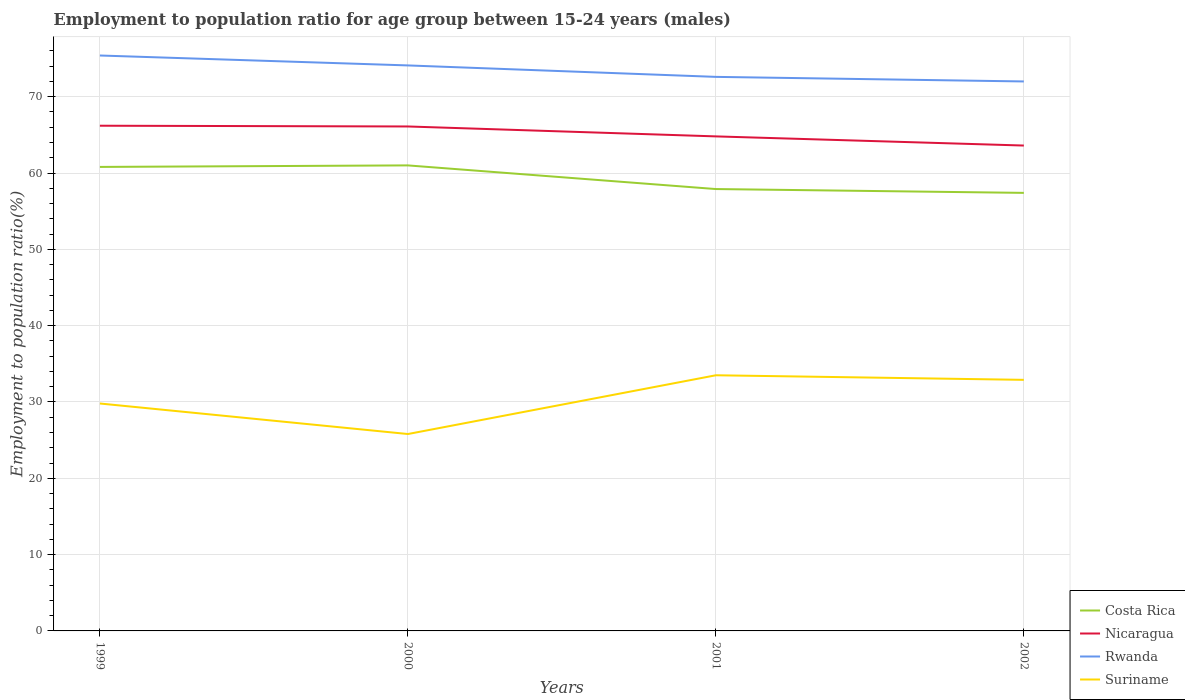How many different coloured lines are there?
Provide a short and direct response. 4. Is the number of lines equal to the number of legend labels?
Your answer should be very brief. Yes. Across all years, what is the maximum employment to population ratio in Suriname?
Make the answer very short. 25.8. In which year was the employment to population ratio in Rwanda maximum?
Make the answer very short. 2002. What is the total employment to population ratio in Suriname in the graph?
Keep it short and to the point. -7.7. What is the difference between the highest and the second highest employment to population ratio in Nicaragua?
Make the answer very short. 2.6. How many lines are there?
Make the answer very short. 4. How many years are there in the graph?
Give a very brief answer. 4. How are the legend labels stacked?
Offer a terse response. Vertical. What is the title of the graph?
Ensure brevity in your answer.  Employment to population ratio for age group between 15-24 years (males). Does "Low income" appear as one of the legend labels in the graph?
Ensure brevity in your answer.  No. What is the label or title of the Y-axis?
Give a very brief answer. Employment to population ratio(%). What is the Employment to population ratio(%) of Costa Rica in 1999?
Provide a succinct answer. 60.8. What is the Employment to population ratio(%) in Nicaragua in 1999?
Your answer should be compact. 66.2. What is the Employment to population ratio(%) of Rwanda in 1999?
Keep it short and to the point. 75.4. What is the Employment to population ratio(%) of Suriname in 1999?
Your answer should be compact. 29.8. What is the Employment to population ratio(%) of Nicaragua in 2000?
Ensure brevity in your answer.  66.1. What is the Employment to population ratio(%) in Rwanda in 2000?
Make the answer very short. 74.1. What is the Employment to population ratio(%) in Suriname in 2000?
Offer a terse response. 25.8. What is the Employment to population ratio(%) of Costa Rica in 2001?
Provide a succinct answer. 57.9. What is the Employment to population ratio(%) of Nicaragua in 2001?
Make the answer very short. 64.8. What is the Employment to population ratio(%) of Rwanda in 2001?
Ensure brevity in your answer.  72.6. What is the Employment to population ratio(%) in Suriname in 2001?
Make the answer very short. 33.5. What is the Employment to population ratio(%) of Costa Rica in 2002?
Offer a very short reply. 57.4. What is the Employment to population ratio(%) in Nicaragua in 2002?
Provide a short and direct response. 63.6. What is the Employment to population ratio(%) of Rwanda in 2002?
Offer a very short reply. 72. What is the Employment to population ratio(%) in Suriname in 2002?
Your answer should be very brief. 32.9. Across all years, what is the maximum Employment to population ratio(%) in Nicaragua?
Offer a terse response. 66.2. Across all years, what is the maximum Employment to population ratio(%) in Rwanda?
Your response must be concise. 75.4. Across all years, what is the maximum Employment to population ratio(%) in Suriname?
Give a very brief answer. 33.5. Across all years, what is the minimum Employment to population ratio(%) in Costa Rica?
Give a very brief answer. 57.4. Across all years, what is the minimum Employment to population ratio(%) of Nicaragua?
Your answer should be very brief. 63.6. Across all years, what is the minimum Employment to population ratio(%) of Suriname?
Provide a succinct answer. 25.8. What is the total Employment to population ratio(%) of Costa Rica in the graph?
Your answer should be very brief. 237.1. What is the total Employment to population ratio(%) of Nicaragua in the graph?
Your response must be concise. 260.7. What is the total Employment to population ratio(%) in Rwanda in the graph?
Offer a very short reply. 294.1. What is the total Employment to population ratio(%) of Suriname in the graph?
Provide a short and direct response. 122. What is the difference between the Employment to population ratio(%) in Rwanda in 1999 and that in 2000?
Provide a short and direct response. 1.3. What is the difference between the Employment to population ratio(%) in Costa Rica in 1999 and that in 2001?
Your response must be concise. 2.9. What is the difference between the Employment to population ratio(%) of Rwanda in 1999 and that in 2001?
Provide a succinct answer. 2.8. What is the difference between the Employment to population ratio(%) of Rwanda in 1999 and that in 2002?
Keep it short and to the point. 3.4. What is the difference between the Employment to population ratio(%) in Costa Rica in 2000 and that in 2001?
Your answer should be compact. 3.1. What is the difference between the Employment to population ratio(%) in Nicaragua in 2000 and that in 2002?
Ensure brevity in your answer.  2.5. What is the difference between the Employment to population ratio(%) of Rwanda in 2001 and that in 2002?
Your response must be concise. 0.6. What is the difference between the Employment to population ratio(%) in Suriname in 2001 and that in 2002?
Provide a short and direct response. 0.6. What is the difference between the Employment to population ratio(%) of Costa Rica in 1999 and the Employment to population ratio(%) of Nicaragua in 2000?
Offer a very short reply. -5.3. What is the difference between the Employment to population ratio(%) in Costa Rica in 1999 and the Employment to population ratio(%) in Rwanda in 2000?
Your answer should be compact. -13.3. What is the difference between the Employment to population ratio(%) in Costa Rica in 1999 and the Employment to population ratio(%) in Suriname in 2000?
Give a very brief answer. 35. What is the difference between the Employment to population ratio(%) of Nicaragua in 1999 and the Employment to population ratio(%) of Suriname in 2000?
Provide a succinct answer. 40.4. What is the difference between the Employment to population ratio(%) in Rwanda in 1999 and the Employment to population ratio(%) in Suriname in 2000?
Keep it short and to the point. 49.6. What is the difference between the Employment to population ratio(%) of Costa Rica in 1999 and the Employment to population ratio(%) of Nicaragua in 2001?
Provide a short and direct response. -4. What is the difference between the Employment to population ratio(%) in Costa Rica in 1999 and the Employment to population ratio(%) in Suriname in 2001?
Ensure brevity in your answer.  27.3. What is the difference between the Employment to population ratio(%) of Nicaragua in 1999 and the Employment to population ratio(%) of Suriname in 2001?
Give a very brief answer. 32.7. What is the difference between the Employment to population ratio(%) of Rwanda in 1999 and the Employment to population ratio(%) of Suriname in 2001?
Your answer should be very brief. 41.9. What is the difference between the Employment to population ratio(%) in Costa Rica in 1999 and the Employment to population ratio(%) in Nicaragua in 2002?
Keep it short and to the point. -2.8. What is the difference between the Employment to population ratio(%) in Costa Rica in 1999 and the Employment to population ratio(%) in Suriname in 2002?
Provide a succinct answer. 27.9. What is the difference between the Employment to population ratio(%) in Nicaragua in 1999 and the Employment to population ratio(%) in Suriname in 2002?
Provide a succinct answer. 33.3. What is the difference between the Employment to population ratio(%) of Rwanda in 1999 and the Employment to population ratio(%) of Suriname in 2002?
Your answer should be compact. 42.5. What is the difference between the Employment to population ratio(%) of Costa Rica in 2000 and the Employment to population ratio(%) of Nicaragua in 2001?
Your answer should be very brief. -3.8. What is the difference between the Employment to population ratio(%) in Nicaragua in 2000 and the Employment to population ratio(%) in Rwanda in 2001?
Provide a short and direct response. -6.5. What is the difference between the Employment to population ratio(%) in Nicaragua in 2000 and the Employment to population ratio(%) in Suriname in 2001?
Offer a terse response. 32.6. What is the difference between the Employment to population ratio(%) of Rwanda in 2000 and the Employment to population ratio(%) of Suriname in 2001?
Make the answer very short. 40.6. What is the difference between the Employment to population ratio(%) of Costa Rica in 2000 and the Employment to population ratio(%) of Nicaragua in 2002?
Offer a terse response. -2.6. What is the difference between the Employment to population ratio(%) in Costa Rica in 2000 and the Employment to population ratio(%) in Suriname in 2002?
Keep it short and to the point. 28.1. What is the difference between the Employment to population ratio(%) of Nicaragua in 2000 and the Employment to population ratio(%) of Suriname in 2002?
Your response must be concise. 33.2. What is the difference between the Employment to population ratio(%) of Rwanda in 2000 and the Employment to population ratio(%) of Suriname in 2002?
Provide a succinct answer. 41.2. What is the difference between the Employment to population ratio(%) in Costa Rica in 2001 and the Employment to population ratio(%) in Rwanda in 2002?
Make the answer very short. -14.1. What is the difference between the Employment to population ratio(%) of Nicaragua in 2001 and the Employment to population ratio(%) of Rwanda in 2002?
Provide a short and direct response. -7.2. What is the difference between the Employment to population ratio(%) of Nicaragua in 2001 and the Employment to population ratio(%) of Suriname in 2002?
Your answer should be compact. 31.9. What is the difference between the Employment to population ratio(%) in Rwanda in 2001 and the Employment to population ratio(%) in Suriname in 2002?
Give a very brief answer. 39.7. What is the average Employment to population ratio(%) of Costa Rica per year?
Provide a short and direct response. 59.27. What is the average Employment to population ratio(%) in Nicaragua per year?
Provide a short and direct response. 65.17. What is the average Employment to population ratio(%) of Rwanda per year?
Offer a terse response. 73.53. What is the average Employment to population ratio(%) in Suriname per year?
Make the answer very short. 30.5. In the year 1999, what is the difference between the Employment to population ratio(%) of Costa Rica and Employment to population ratio(%) of Nicaragua?
Your answer should be very brief. -5.4. In the year 1999, what is the difference between the Employment to population ratio(%) of Costa Rica and Employment to population ratio(%) of Rwanda?
Offer a very short reply. -14.6. In the year 1999, what is the difference between the Employment to population ratio(%) in Costa Rica and Employment to population ratio(%) in Suriname?
Offer a terse response. 31. In the year 1999, what is the difference between the Employment to population ratio(%) of Nicaragua and Employment to population ratio(%) of Rwanda?
Give a very brief answer. -9.2. In the year 1999, what is the difference between the Employment to population ratio(%) in Nicaragua and Employment to population ratio(%) in Suriname?
Your answer should be compact. 36.4. In the year 1999, what is the difference between the Employment to population ratio(%) in Rwanda and Employment to population ratio(%) in Suriname?
Keep it short and to the point. 45.6. In the year 2000, what is the difference between the Employment to population ratio(%) of Costa Rica and Employment to population ratio(%) of Suriname?
Keep it short and to the point. 35.2. In the year 2000, what is the difference between the Employment to population ratio(%) in Nicaragua and Employment to population ratio(%) in Suriname?
Ensure brevity in your answer.  40.3. In the year 2000, what is the difference between the Employment to population ratio(%) of Rwanda and Employment to population ratio(%) of Suriname?
Your response must be concise. 48.3. In the year 2001, what is the difference between the Employment to population ratio(%) in Costa Rica and Employment to population ratio(%) in Rwanda?
Your answer should be compact. -14.7. In the year 2001, what is the difference between the Employment to population ratio(%) in Costa Rica and Employment to population ratio(%) in Suriname?
Offer a terse response. 24.4. In the year 2001, what is the difference between the Employment to population ratio(%) in Nicaragua and Employment to population ratio(%) in Suriname?
Give a very brief answer. 31.3. In the year 2001, what is the difference between the Employment to population ratio(%) of Rwanda and Employment to population ratio(%) of Suriname?
Provide a short and direct response. 39.1. In the year 2002, what is the difference between the Employment to population ratio(%) of Costa Rica and Employment to population ratio(%) of Rwanda?
Offer a very short reply. -14.6. In the year 2002, what is the difference between the Employment to population ratio(%) of Nicaragua and Employment to population ratio(%) of Suriname?
Ensure brevity in your answer.  30.7. In the year 2002, what is the difference between the Employment to population ratio(%) in Rwanda and Employment to population ratio(%) in Suriname?
Your answer should be compact. 39.1. What is the ratio of the Employment to population ratio(%) of Costa Rica in 1999 to that in 2000?
Make the answer very short. 1. What is the ratio of the Employment to population ratio(%) of Nicaragua in 1999 to that in 2000?
Keep it short and to the point. 1. What is the ratio of the Employment to population ratio(%) in Rwanda in 1999 to that in 2000?
Provide a succinct answer. 1.02. What is the ratio of the Employment to population ratio(%) of Suriname in 1999 to that in 2000?
Keep it short and to the point. 1.16. What is the ratio of the Employment to population ratio(%) of Costa Rica in 1999 to that in 2001?
Provide a succinct answer. 1.05. What is the ratio of the Employment to population ratio(%) in Nicaragua in 1999 to that in 2001?
Provide a short and direct response. 1.02. What is the ratio of the Employment to population ratio(%) in Rwanda in 1999 to that in 2001?
Make the answer very short. 1.04. What is the ratio of the Employment to population ratio(%) of Suriname in 1999 to that in 2001?
Keep it short and to the point. 0.89. What is the ratio of the Employment to population ratio(%) of Costa Rica in 1999 to that in 2002?
Give a very brief answer. 1.06. What is the ratio of the Employment to population ratio(%) of Nicaragua in 1999 to that in 2002?
Make the answer very short. 1.04. What is the ratio of the Employment to population ratio(%) in Rwanda in 1999 to that in 2002?
Your answer should be very brief. 1.05. What is the ratio of the Employment to population ratio(%) in Suriname in 1999 to that in 2002?
Your answer should be very brief. 0.91. What is the ratio of the Employment to population ratio(%) of Costa Rica in 2000 to that in 2001?
Provide a short and direct response. 1.05. What is the ratio of the Employment to population ratio(%) of Nicaragua in 2000 to that in 2001?
Offer a terse response. 1.02. What is the ratio of the Employment to population ratio(%) of Rwanda in 2000 to that in 2001?
Provide a succinct answer. 1.02. What is the ratio of the Employment to population ratio(%) of Suriname in 2000 to that in 2001?
Provide a short and direct response. 0.77. What is the ratio of the Employment to population ratio(%) in Costa Rica in 2000 to that in 2002?
Give a very brief answer. 1.06. What is the ratio of the Employment to population ratio(%) of Nicaragua in 2000 to that in 2002?
Offer a very short reply. 1.04. What is the ratio of the Employment to population ratio(%) of Rwanda in 2000 to that in 2002?
Keep it short and to the point. 1.03. What is the ratio of the Employment to population ratio(%) of Suriname in 2000 to that in 2002?
Your response must be concise. 0.78. What is the ratio of the Employment to population ratio(%) of Costa Rica in 2001 to that in 2002?
Provide a short and direct response. 1.01. What is the ratio of the Employment to population ratio(%) in Nicaragua in 2001 to that in 2002?
Give a very brief answer. 1.02. What is the ratio of the Employment to population ratio(%) of Rwanda in 2001 to that in 2002?
Ensure brevity in your answer.  1.01. What is the ratio of the Employment to population ratio(%) in Suriname in 2001 to that in 2002?
Offer a terse response. 1.02. What is the difference between the highest and the second highest Employment to population ratio(%) in Costa Rica?
Your answer should be very brief. 0.2. What is the difference between the highest and the second highest Employment to population ratio(%) in Rwanda?
Ensure brevity in your answer.  1.3. What is the difference between the highest and the second highest Employment to population ratio(%) of Suriname?
Ensure brevity in your answer.  0.6. What is the difference between the highest and the lowest Employment to population ratio(%) in Costa Rica?
Give a very brief answer. 3.6. What is the difference between the highest and the lowest Employment to population ratio(%) of Rwanda?
Make the answer very short. 3.4. 